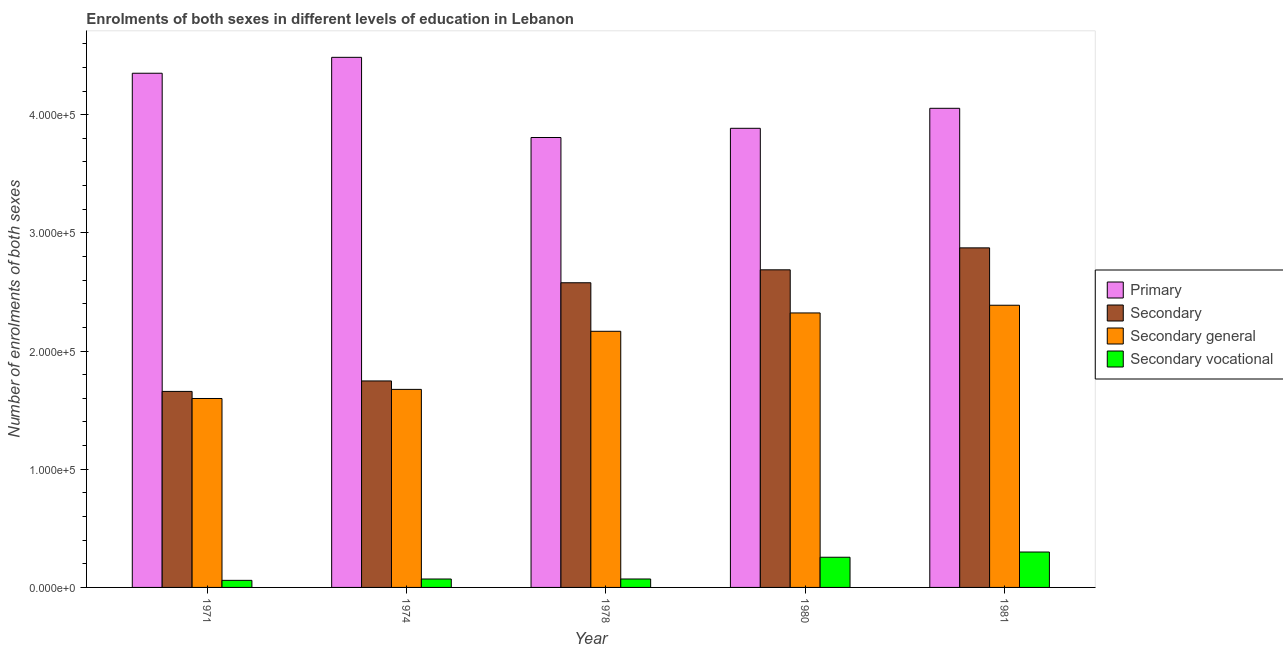How many groups of bars are there?
Provide a succinct answer. 5. Are the number of bars on each tick of the X-axis equal?
Ensure brevity in your answer.  Yes. How many bars are there on the 4th tick from the left?
Ensure brevity in your answer.  4. How many bars are there on the 1st tick from the right?
Your answer should be very brief. 4. What is the number of enrolments in secondary education in 1980?
Provide a succinct answer. 2.69e+05. Across all years, what is the maximum number of enrolments in secondary education?
Provide a succinct answer. 2.87e+05. Across all years, what is the minimum number of enrolments in secondary general education?
Your answer should be very brief. 1.60e+05. In which year was the number of enrolments in secondary education maximum?
Offer a terse response. 1981. What is the total number of enrolments in primary education in the graph?
Your response must be concise. 2.06e+06. What is the difference between the number of enrolments in secondary education in 1974 and that in 1980?
Your answer should be very brief. -9.40e+04. What is the difference between the number of enrolments in secondary general education in 1971 and the number of enrolments in secondary education in 1974?
Make the answer very short. -7707. What is the average number of enrolments in secondary education per year?
Ensure brevity in your answer.  2.31e+05. In how many years, is the number of enrolments in primary education greater than 180000?
Provide a succinct answer. 5. What is the ratio of the number of enrolments in secondary vocational education in 1980 to that in 1981?
Your answer should be very brief. 0.85. Is the difference between the number of enrolments in secondary vocational education in 1971 and 1981 greater than the difference between the number of enrolments in primary education in 1971 and 1981?
Your answer should be compact. No. What is the difference between the highest and the second highest number of enrolments in primary education?
Provide a succinct answer. 1.35e+04. What is the difference between the highest and the lowest number of enrolments in primary education?
Your answer should be compact. 6.78e+04. Is the sum of the number of enrolments in secondary education in 1971 and 1978 greater than the maximum number of enrolments in secondary vocational education across all years?
Your answer should be compact. Yes. Is it the case that in every year, the sum of the number of enrolments in secondary general education and number of enrolments in primary education is greater than the sum of number of enrolments in secondary vocational education and number of enrolments in secondary education?
Offer a terse response. Yes. What does the 4th bar from the left in 1980 represents?
Your response must be concise. Secondary vocational. What does the 1st bar from the right in 1974 represents?
Provide a succinct answer. Secondary vocational. Is it the case that in every year, the sum of the number of enrolments in primary education and number of enrolments in secondary education is greater than the number of enrolments in secondary general education?
Provide a short and direct response. Yes. How many years are there in the graph?
Your answer should be compact. 5. Are the values on the major ticks of Y-axis written in scientific E-notation?
Provide a short and direct response. Yes. Does the graph contain grids?
Provide a succinct answer. No. How are the legend labels stacked?
Your answer should be very brief. Vertical. What is the title of the graph?
Make the answer very short. Enrolments of both sexes in different levels of education in Lebanon. Does "Social equity" appear as one of the legend labels in the graph?
Keep it short and to the point. No. What is the label or title of the Y-axis?
Offer a terse response. Number of enrolments of both sexes. What is the Number of enrolments of both sexes in Primary in 1971?
Your answer should be compact. 4.35e+05. What is the Number of enrolments of both sexes of Secondary in 1971?
Offer a very short reply. 1.66e+05. What is the Number of enrolments of both sexes in Secondary general in 1971?
Your response must be concise. 1.60e+05. What is the Number of enrolments of both sexes of Secondary vocational in 1971?
Make the answer very short. 5983. What is the Number of enrolments of both sexes of Primary in 1974?
Keep it short and to the point. 4.49e+05. What is the Number of enrolments of both sexes in Secondary in 1974?
Offer a very short reply. 1.75e+05. What is the Number of enrolments of both sexes in Secondary general in 1974?
Give a very brief answer. 1.68e+05. What is the Number of enrolments of both sexes of Secondary vocational in 1974?
Offer a terse response. 7117. What is the Number of enrolments of both sexes in Primary in 1978?
Your answer should be very brief. 3.81e+05. What is the Number of enrolments of both sexes in Secondary in 1978?
Make the answer very short. 2.58e+05. What is the Number of enrolments of both sexes of Secondary general in 1978?
Provide a short and direct response. 2.17e+05. What is the Number of enrolments of both sexes in Secondary vocational in 1978?
Your answer should be very brief. 7133. What is the Number of enrolments of both sexes of Primary in 1980?
Offer a terse response. 3.88e+05. What is the Number of enrolments of both sexes in Secondary in 1980?
Make the answer very short. 2.69e+05. What is the Number of enrolments of both sexes in Secondary general in 1980?
Keep it short and to the point. 2.32e+05. What is the Number of enrolments of both sexes of Secondary vocational in 1980?
Offer a terse response. 2.55e+04. What is the Number of enrolments of both sexes in Primary in 1981?
Provide a succinct answer. 4.05e+05. What is the Number of enrolments of both sexes in Secondary in 1981?
Provide a short and direct response. 2.87e+05. What is the Number of enrolments of both sexes of Secondary general in 1981?
Give a very brief answer. 2.39e+05. What is the Number of enrolments of both sexes in Secondary vocational in 1981?
Your answer should be very brief. 3.00e+04. Across all years, what is the maximum Number of enrolments of both sexes of Primary?
Ensure brevity in your answer.  4.49e+05. Across all years, what is the maximum Number of enrolments of both sexes of Secondary?
Keep it short and to the point. 2.87e+05. Across all years, what is the maximum Number of enrolments of both sexes of Secondary general?
Provide a short and direct response. 2.39e+05. Across all years, what is the maximum Number of enrolments of both sexes of Secondary vocational?
Your response must be concise. 3.00e+04. Across all years, what is the minimum Number of enrolments of both sexes in Primary?
Offer a very short reply. 3.81e+05. Across all years, what is the minimum Number of enrolments of both sexes in Secondary?
Your answer should be very brief. 1.66e+05. Across all years, what is the minimum Number of enrolments of both sexes of Secondary general?
Your answer should be compact. 1.60e+05. Across all years, what is the minimum Number of enrolments of both sexes in Secondary vocational?
Offer a terse response. 5983. What is the total Number of enrolments of both sexes of Primary in the graph?
Provide a short and direct response. 2.06e+06. What is the total Number of enrolments of both sexes in Secondary in the graph?
Make the answer very short. 1.15e+06. What is the total Number of enrolments of both sexes of Secondary general in the graph?
Make the answer very short. 1.02e+06. What is the total Number of enrolments of both sexes in Secondary vocational in the graph?
Keep it short and to the point. 7.57e+04. What is the difference between the Number of enrolments of both sexes in Primary in 1971 and that in 1974?
Your response must be concise. -1.35e+04. What is the difference between the Number of enrolments of both sexes of Secondary in 1971 and that in 1974?
Give a very brief answer. -8857. What is the difference between the Number of enrolments of both sexes in Secondary general in 1971 and that in 1974?
Give a very brief answer. -7707. What is the difference between the Number of enrolments of both sexes in Secondary vocational in 1971 and that in 1974?
Offer a very short reply. -1134. What is the difference between the Number of enrolments of both sexes of Primary in 1971 and that in 1978?
Offer a terse response. 5.44e+04. What is the difference between the Number of enrolments of both sexes in Secondary in 1971 and that in 1978?
Provide a short and direct response. -9.19e+04. What is the difference between the Number of enrolments of both sexes of Secondary general in 1971 and that in 1978?
Provide a succinct answer. -5.69e+04. What is the difference between the Number of enrolments of both sexes in Secondary vocational in 1971 and that in 1978?
Provide a short and direct response. -1150. What is the difference between the Number of enrolments of both sexes in Primary in 1971 and that in 1980?
Offer a terse response. 4.66e+04. What is the difference between the Number of enrolments of both sexes of Secondary in 1971 and that in 1980?
Make the answer very short. -1.03e+05. What is the difference between the Number of enrolments of both sexes in Secondary general in 1971 and that in 1980?
Offer a very short reply. -7.24e+04. What is the difference between the Number of enrolments of both sexes of Secondary vocational in 1971 and that in 1980?
Make the answer very short. -1.96e+04. What is the difference between the Number of enrolments of both sexes of Primary in 1971 and that in 1981?
Provide a short and direct response. 2.97e+04. What is the difference between the Number of enrolments of both sexes of Secondary in 1971 and that in 1981?
Your answer should be compact. -1.21e+05. What is the difference between the Number of enrolments of both sexes in Secondary general in 1971 and that in 1981?
Offer a terse response. -7.89e+04. What is the difference between the Number of enrolments of both sexes in Secondary vocational in 1971 and that in 1981?
Your response must be concise. -2.40e+04. What is the difference between the Number of enrolments of both sexes in Primary in 1974 and that in 1978?
Offer a very short reply. 6.78e+04. What is the difference between the Number of enrolments of both sexes of Secondary in 1974 and that in 1978?
Keep it short and to the point. -8.31e+04. What is the difference between the Number of enrolments of both sexes of Secondary general in 1974 and that in 1978?
Your response must be concise. -4.92e+04. What is the difference between the Number of enrolments of both sexes of Primary in 1974 and that in 1980?
Your response must be concise. 6.01e+04. What is the difference between the Number of enrolments of both sexes in Secondary in 1974 and that in 1980?
Keep it short and to the point. -9.40e+04. What is the difference between the Number of enrolments of both sexes of Secondary general in 1974 and that in 1980?
Offer a terse response. -6.47e+04. What is the difference between the Number of enrolments of both sexes in Secondary vocational in 1974 and that in 1980?
Make the answer very short. -1.84e+04. What is the difference between the Number of enrolments of both sexes in Primary in 1974 and that in 1981?
Offer a very short reply. 4.31e+04. What is the difference between the Number of enrolments of both sexes of Secondary in 1974 and that in 1981?
Ensure brevity in your answer.  -1.13e+05. What is the difference between the Number of enrolments of both sexes in Secondary general in 1974 and that in 1981?
Ensure brevity in your answer.  -7.12e+04. What is the difference between the Number of enrolments of both sexes of Secondary vocational in 1974 and that in 1981?
Your answer should be compact. -2.28e+04. What is the difference between the Number of enrolments of both sexes in Primary in 1978 and that in 1980?
Make the answer very short. -7787. What is the difference between the Number of enrolments of both sexes of Secondary in 1978 and that in 1980?
Keep it short and to the point. -1.09e+04. What is the difference between the Number of enrolments of both sexes in Secondary general in 1978 and that in 1980?
Your answer should be very brief. -1.55e+04. What is the difference between the Number of enrolments of both sexes in Secondary vocational in 1978 and that in 1980?
Offer a very short reply. -1.84e+04. What is the difference between the Number of enrolments of both sexes of Primary in 1978 and that in 1981?
Make the answer very short. -2.47e+04. What is the difference between the Number of enrolments of both sexes of Secondary in 1978 and that in 1981?
Make the answer very short. -2.95e+04. What is the difference between the Number of enrolments of both sexes of Secondary general in 1978 and that in 1981?
Offer a very short reply. -2.20e+04. What is the difference between the Number of enrolments of both sexes in Secondary vocational in 1978 and that in 1981?
Ensure brevity in your answer.  -2.28e+04. What is the difference between the Number of enrolments of both sexes of Primary in 1980 and that in 1981?
Ensure brevity in your answer.  -1.69e+04. What is the difference between the Number of enrolments of both sexes of Secondary in 1980 and that in 1981?
Provide a short and direct response. -1.86e+04. What is the difference between the Number of enrolments of both sexes of Secondary general in 1980 and that in 1981?
Your response must be concise. -6518. What is the difference between the Number of enrolments of both sexes in Secondary vocational in 1980 and that in 1981?
Make the answer very short. -4417. What is the difference between the Number of enrolments of both sexes in Primary in 1971 and the Number of enrolments of both sexes in Secondary in 1974?
Provide a short and direct response. 2.60e+05. What is the difference between the Number of enrolments of both sexes in Primary in 1971 and the Number of enrolments of both sexes in Secondary general in 1974?
Ensure brevity in your answer.  2.67e+05. What is the difference between the Number of enrolments of both sexes in Primary in 1971 and the Number of enrolments of both sexes in Secondary vocational in 1974?
Your answer should be compact. 4.28e+05. What is the difference between the Number of enrolments of both sexes in Secondary in 1971 and the Number of enrolments of both sexes in Secondary general in 1974?
Provide a succinct answer. -1724. What is the difference between the Number of enrolments of both sexes in Secondary in 1971 and the Number of enrolments of both sexes in Secondary vocational in 1974?
Provide a succinct answer. 1.59e+05. What is the difference between the Number of enrolments of both sexes in Secondary general in 1971 and the Number of enrolments of both sexes in Secondary vocational in 1974?
Ensure brevity in your answer.  1.53e+05. What is the difference between the Number of enrolments of both sexes in Primary in 1971 and the Number of enrolments of both sexes in Secondary in 1978?
Provide a short and direct response. 1.77e+05. What is the difference between the Number of enrolments of both sexes in Primary in 1971 and the Number of enrolments of both sexes in Secondary general in 1978?
Give a very brief answer. 2.18e+05. What is the difference between the Number of enrolments of both sexes of Primary in 1971 and the Number of enrolments of both sexes of Secondary vocational in 1978?
Your answer should be compact. 4.28e+05. What is the difference between the Number of enrolments of both sexes of Secondary in 1971 and the Number of enrolments of both sexes of Secondary general in 1978?
Your response must be concise. -5.09e+04. What is the difference between the Number of enrolments of both sexes of Secondary in 1971 and the Number of enrolments of both sexes of Secondary vocational in 1978?
Keep it short and to the point. 1.59e+05. What is the difference between the Number of enrolments of both sexes in Secondary general in 1971 and the Number of enrolments of both sexes in Secondary vocational in 1978?
Offer a terse response. 1.53e+05. What is the difference between the Number of enrolments of both sexes in Primary in 1971 and the Number of enrolments of both sexes in Secondary in 1980?
Provide a succinct answer. 1.66e+05. What is the difference between the Number of enrolments of both sexes in Primary in 1971 and the Number of enrolments of both sexes in Secondary general in 1980?
Ensure brevity in your answer.  2.03e+05. What is the difference between the Number of enrolments of both sexes of Primary in 1971 and the Number of enrolments of both sexes of Secondary vocational in 1980?
Offer a very short reply. 4.10e+05. What is the difference between the Number of enrolments of both sexes of Secondary in 1971 and the Number of enrolments of both sexes of Secondary general in 1980?
Offer a very short reply. -6.64e+04. What is the difference between the Number of enrolments of both sexes of Secondary in 1971 and the Number of enrolments of both sexes of Secondary vocational in 1980?
Your response must be concise. 1.40e+05. What is the difference between the Number of enrolments of both sexes of Secondary general in 1971 and the Number of enrolments of both sexes of Secondary vocational in 1980?
Offer a terse response. 1.34e+05. What is the difference between the Number of enrolments of both sexes in Primary in 1971 and the Number of enrolments of both sexes in Secondary in 1981?
Ensure brevity in your answer.  1.48e+05. What is the difference between the Number of enrolments of both sexes in Primary in 1971 and the Number of enrolments of both sexes in Secondary general in 1981?
Your answer should be very brief. 1.96e+05. What is the difference between the Number of enrolments of both sexes in Primary in 1971 and the Number of enrolments of both sexes in Secondary vocational in 1981?
Offer a terse response. 4.05e+05. What is the difference between the Number of enrolments of both sexes of Secondary in 1971 and the Number of enrolments of both sexes of Secondary general in 1981?
Provide a succinct answer. -7.29e+04. What is the difference between the Number of enrolments of both sexes of Secondary in 1971 and the Number of enrolments of both sexes of Secondary vocational in 1981?
Offer a terse response. 1.36e+05. What is the difference between the Number of enrolments of both sexes in Secondary general in 1971 and the Number of enrolments of both sexes in Secondary vocational in 1981?
Provide a succinct answer. 1.30e+05. What is the difference between the Number of enrolments of both sexes in Primary in 1974 and the Number of enrolments of both sexes in Secondary in 1978?
Offer a terse response. 1.91e+05. What is the difference between the Number of enrolments of both sexes of Primary in 1974 and the Number of enrolments of both sexes of Secondary general in 1978?
Ensure brevity in your answer.  2.32e+05. What is the difference between the Number of enrolments of both sexes in Primary in 1974 and the Number of enrolments of both sexes in Secondary vocational in 1978?
Keep it short and to the point. 4.41e+05. What is the difference between the Number of enrolments of both sexes of Secondary in 1974 and the Number of enrolments of both sexes of Secondary general in 1978?
Your response must be concise. -4.20e+04. What is the difference between the Number of enrolments of both sexes in Secondary in 1974 and the Number of enrolments of both sexes in Secondary vocational in 1978?
Offer a terse response. 1.68e+05. What is the difference between the Number of enrolments of both sexes in Secondary general in 1974 and the Number of enrolments of both sexes in Secondary vocational in 1978?
Make the answer very short. 1.60e+05. What is the difference between the Number of enrolments of both sexes in Primary in 1974 and the Number of enrolments of both sexes in Secondary in 1980?
Ensure brevity in your answer.  1.80e+05. What is the difference between the Number of enrolments of both sexes of Primary in 1974 and the Number of enrolments of both sexes of Secondary general in 1980?
Offer a very short reply. 2.16e+05. What is the difference between the Number of enrolments of both sexes of Primary in 1974 and the Number of enrolments of both sexes of Secondary vocational in 1980?
Offer a terse response. 4.23e+05. What is the difference between the Number of enrolments of both sexes in Secondary in 1974 and the Number of enrolments of both sexes in Secondary general in 1980?
Offer a terse response. -5.75e+04. What is the difference between the Number of enrolments of both sexes of Secondary in 1974 and the Number of enrolments of both sexes of Secondary vocational in 1980?
Keep it short and to the point. 1.49e+05. What is the difference between the Number of enrolments of both sexes of Secondary general in 1974 and the Number of enrolments of both sexes of Secondary vocational in 1980?
Ensure brevity in your answer.  1.42e+05. What is the difference between the Number of enrolments of both sexes in Primary in 1974 and the Number of enrolments of both sexes in Secondary in 1981?
Give a very brief answer. 1.61e+05. What is the difference between the Number of enrolments of both sexes of Primary in 1974 and the Number of enrolments of both sexes of Secondary general in 1981?
Ensure brevity in your answer.  2.10e+05. What is the difference between the Number of enrolments of both sexes of Primary in 1974 and the Number of enrolments of both sexes of Secondary vocational in 1981?
Your answer should be very brief. 4.19e+05. What is the difference between the Number of enrolments of both sexes of Secondary in 1974 and the Number of enrolments of both sexes of Secondary general in 1981?
Keep it short and to the point. -6.41e+04. What is the difference between the Number of enrolments of both sexes of Secondary in 1974 and the Number of enrolments of both sexes of Secondary vocational in 1981?
Keep it short and to the point. 1.45e+05. What is the difference between the Number of enrolments of both sexes in Secondary general in 1974 and the Number of enrolments of both sexes in Secondary vocational in 1981?
Keep it short and to the point. 1.38e+05. What is the difference between the Number of enrolments of both sexes of Primary in 1978 and the Number of enrolments of both sexes of Secondary in 1980?
Your response must be concise. 1.12e+05. What is the difference between the Number of enrolments of both sexes of Primary in 1978 and the Number of enrolments of both sexes of Secondary general in 1980?
Make the answer very short. 1.48e+05. What is the difference between the Number of enrolments of both sexes in Primary in 1978 and the Number of enrolments of both sexes in Secondary vocational in 1980?
Keep it short and to the point. 3.55e+05. What is the difference between the Number of enrolments of both sexes in Secondary in 1978 and the Number of enrolments of both sexes in Secondary general in 1980?
Offer a very short reply. 2.55e+04. What is the difference between the Number of enrolments of both sexes of Secondary in 1978 and the Number of enrolments of both sexes of Secondary vocational in 1980?
Offer a terse response. 2.32e+05. What is the difference between the Number of enrolments of both sexes of Secondary general in 1978 and the Number of enrolments of both sexes of Secondary vocational in 1980?
Offer a very short reply. 1.91e+05. What is the difference between the Number of enrolments of both sexes in Primary in 1978 and the Number of enrolments of both sexes in Secondary in 1981?
Provide a short and direct response. 9.34e+04. What is the difference between the Number of enrolments of both sexes in Primary in 1978 and the Number of enrolments of both sexes in Secondary general in 1981?
Your answer should be compact. 1.42e+05. What is the difference between the Number of enrolments of both sexes of Primary in 1978 and the Number of enrolments of both sexes of Secondary vocational in 1981?
Ensure brevity in your answer.  3.51e+05. What is the difference between the Number of enrolments of both sexes of Secondary in 1978 and the Number of enrolments of both sexes of Secondary general in 1981?
Your answer should be very brief. 1.90e+04. What is the difference between the Number of enrolments of both sexes in Secondary in 1978 and the Number of enrolments of both sexes in Secondary vocational in 1981?
Make the answer very short. 2.28e+05. What is the difference between the Number of enrolments of both sexes of Secondary general in 1978 and the Number of enrolments of both sexes of Secondary vocational in 1981?
Your response must be concise. 1.87e+05. What is the difference between the Number of enrolments of both sexes in Primary in 1980 and the Number of enrolments of both sexes in Secondary in 1981?
Provide a short and direct response. 1.01e+05. What is the difference between the Number of enrolments of both sexes of Primary in 1980 and the Number of enrolments of both sexes of Secondary general in 1981?
Your response must be concise. 1.50e+05. What is the difference between the Number of enrolments of both sexes of Primary in 1980 and the Number of enrolments of both sexes of Secondary vocational in 1981?
Your answer should be compact. 3.59e+05. What is the difference between the Number of enrolments of both sexes in Secondary in 1980 and the Number of enrolments of both sexes in Secondary general in 1981?
Offer a very short reply. 3.00e+04. What is the difference between the Number of enrolments of both sexes in Secondary in 1980 and the Number of enrolments of both sexes in Secondary vocational in 1981?
Offer a terse response. 2.39e+05. What is the difference between the Number of enrolments of both sexes in Secondary general in 1980 and the Number of enrolments of both sexes in Secondary vocational in 1981?
Ensure brevity in your answer.  2.02e+05. What is the average Number of enrolments of both sexes of Primary per year?
Your answer should be very brief. 4.12e+05. What is the average Number of enrolments of both sexes in Secondary per year?
Provide a succinct answer. 2.31e+05. What is the average Number of enrolments of both sexes of Secondary general per year?
Provide a short and direct response. 2.03e+05. What is the average Number of enrolments of both sexes of Secondary vocational per year?
Your answer should be compact. 1.51e+04. In the year 1971, what is the difference between the Number of enrolments of both sexes of Primary and Number of enrolments of both sexes of Secondary?
Your answer should be very brief. 2.69e+05. In the year 1971, what is the difference between the Number of enrolments of both sexes in Primary and Number of enrolments of both sexes in Secondary general?
Make the answer very short. 2.75e+05. In the year 1971, what is the difference between the Number of enrolments of both sexes in Primary and Number of enrolments of both sexes in Secondary vocational?
Your response must be concise. 4.29e+05. In the year 1971, what is the difference between the Number of enrolments of both sexes of Secondary and Number of enrolments of both sexes of Secondary general?
Give a very brief answer. 5983. In the year 1971, what is the difference between the Number of enrolments of both sexes in Secondary and Number of enrolments of both sexes in Secondary vocational?
Give a very brief answer. 1.60e+05. In the year 1971, what is the difference between the Number of enrolments of both sexes of Secondary general and Number of enrolments of both sexes of Secondary vocational?
Your answer should be compact. 1.54e+05. In the year 1974, what is the difference between the Number of enrolments of both sexes of Primary and Number of enrolments of both sexes of Secondary?
Give a very brief answer. 2.74e+05. In the year 1974, what is the difference between the Number of enrolments of both sexes of Primary and Number of enrolments of both sexes of Secondary general?
Your answer should be compact. 2.81e+05. In the year 1974, what is the difference between the Number of enrolments of both sexes in Primary and Number of enrolments of both sexes in Secondary vocational?
Your answer should be compact. 4.41e+05. In the year 1974, what is the difference between the Number of enrolments of both sexes in Secondary and Number of enrolments of both sexes in Secondary general?
Provide a short and direct response. 7133. In the year 1974, what is the difference between the Number of enrolments of both sexes in Secondary and Number of enrolments of both sexes in Secondary vocational?
Your response must be concise. 1.68e+05. In the year 1974, what is the difference between the Number of enrolments of both sexes of Secondary general and Number of enrolments of both sexes of Secondary vocational?
Give a very brief answer. 1.60e+05. In the year 1978, what is the difference between the Number of enrolments of both sexes in Primary and Number of enrolments of both sexes in Secondary?
Give a very brief answer. 1.23e+05. In the year 1978, what is the difference between the Number of enrolments of both sexes in Primary and Number of enrolments of both sexes in Secondary general?
Your answer should be compact. 1.64e+05. In the year 1978, what is the difference between the Number of enrolments of both sexes in Primary and Number of enrolments of both sexes in Secondary vocational?
Make the answer very short. 3.74e+05. In the year 1978, what is the difference between the Number of enrolments of both sexes in Secondary and Number of enrolments of both sexes in Secondary general?
Give a very brief answer. 4.11e+04. In the year 1978, what is the difference between the Number of enrolments of both sexes of Secondary and Number of enrolments of both sexes of Secondary vocational?
Your answer should be compact. 2.51e+05. In the year 1978, what is the difference between the Number of enrolments of both sexes of Secondary general and Number of enrolments of both sexes of Secondary vocational?
Keep it short and to the point. 2.10e+05. In the year 1980, what is the difference between the Number of enrolments of both sexes of Primary and Number of enrolments of both sexes of Secondary?
Ensure brevity in your answer.  1.20e+05. In the year 1980, what is the difference between the Number of enrolments of both sexes of Primary and Number of enrolments of both sexes of Secondary general?
Make the answer very short. 1.56e+05. In the year 1980, what is the difference between the Number of enrolments of both sexes of Primary and Number of enrolments of both sexes of Secondary vocational?
Provide a succinct answer. 3.63e+05. In the year 1980, what is the difference between the Number of enrolments of both sexes of Secondary and Number of enrolments of both sexes of Secondary general?
Keep it short and to the point. 3.65e+04. In the year 1980, what is the difference between the Number of enrolments of both sexes in Secondary and Number of enrolments of both sexes in Secondary vocational?
Offer a terse response. 2.43e+05. In the year 1980, what is the difference between the Number of enrolments of both sexes of Secondary general and Number of enrolments of both sexes of Secondary vocational?
Provide a succinct answer. 2.07e+05. In the year 1981, what is the difference between the Number of enrolments of both sexes of Primary and Number of enrolments of both sexes of Secondary?
Provide a short and direct response. 1.18e+05. In the year 1981, what is the difference between the Number of enrolments of both sexes in Primary and Number of enrolments of both sexes in Secondary general?
Provide a short and direct response. 1.67e+05. In the year 1981, what is the difference between the Number of enrolments of both sexes of Primary and Number of enrolments of both sexes of Secondary vocational?
Ensure brevity in your answer.  3.75e+05. In the year 1981, what is the difference between the Number of enrolments of both sexes in Secondary and Number of enrolments of both sexes in Secondary general?
Offer a very short reply. 4.85e+04. In the year 1981, what is the difference between the Number of enrolments of both sexes in Secondary and Number of enrolments of both sexes in Secondary vocational?
Your answer should be compact. 2.57e+05. In the year 1981, what is the difference between the Number of enrolments of both sexes of Secondary general and Number of enrolments of both sexes of Secondary vocational?
Provide a short and direct response. 2.09e+05. What is the ratio of the Number of enrolments of both sexes in Secondary in 1971 to that in 1974?
Your answer should be compact. 0.95. What is the ratio of the Number of enrolments of both sexes in Secondary general in 1971 to that in 1974?
Provide a succinct answer. 0.95. What is the ratio of the Number of enrolments of both sexes in Secondary vocational in 1971 to that in 1974?
Provide a succinct answer. 0.84. What is the ratio of the Number of enrolments of both sexes in Primary in 1971 to that in 1978?
Keep it short and to the point. 1.14. What is the ratio of the Number of enrolments of both sexes of Secondary in 1971 to that in 1978?
Provide a short and direct response. 0.64. What is the ratio of the Number of enrolments of both sexes of Secondary general in 1971 to that in 1978?
Your answer should be compact. 0.74. What is the ratio of the Number of enrolments of both sexes of Secondary vocational in 1971 to that in 1978?
Make the answer very short. 0.84. What is the ratio of the Number of enrolments of both sexes in Primary in 1971 to that in 1980?
Give a very brief answer. 1.12. What is the ratio of the Number of enrolments of both sexes in Secondary in 1971 to that in 1980?
Offer a very short reply. 0.62. What is the ratio of the Number of enrolments of both sexes of Secondary general in 1971 to that in 1980?
Your response must be concise. 0.69. What is the ratio of the Number of enrolments of both sexes in Secondary vocational in 1971 to that in 1980?
Offer a very short reply. 0.23. What is the ratio of the Number of enrolments of both sexes in Primary in 1971 to that in 1981?
Your answer should be compact. 1.07. What is the ratio of the Number of enrolments of both sexes in Secondary in 1971 to that in 1981?
Provide a succinct answer. 0.58. What is the ratio of the Number of enrolments of both sexes in Secondary general in 1971 to that in 1981?
Offer a terse response. 0.67. What is the ratio of the Number of enrolments of both sexes in Secondary vocational in 1971 to that in 1981?
Provide a succinct answer. 0.2. What is the ratio of the Number of enrolments of both sexes of Primary in 1974 to that in 1978?
Offer a very short reply. 1.18. What is the ratio of the Number of enrolments of both sexes in Secondary in 1974 to that in 1978?
Provide a short and direct response. 0.68. What is the ratio of the Number of enrolments of both sexes in Secondary general in 1974 to that in 1978?
Provide a succinct answer. 0.77. What is the ratio of the Number of enrolments of both sexes in Secondary vocational in 1974 to that in 1978?
Your answer should be compact. 1. What is the ratio of the Number of enrolments of both sexes in Primary in 1974 to that in 1980?
Make the answer very short. 1.15. What is the ratio of the Number of enrolments of both sexes in Secondary in 1974 to that in 1980?
Keep it short and to the point. 0.65. What is the ratio of the Number of enrolments of both sexes of Secondary general in 1974 to that in 1980?
Offer a terse response. 0.72. What is the ratio of the Number of enrolments of both sexes in Secondary vocational in 1974 to that in 1980?
Provide a succinct answer. 0.28. What is the ratio of the Number of enrolments of both sexes in Primary in 1974 to that in 1981?
Make the answer very short. 1.11. What is the ratio of the Number of enrolments of both sexes of Secondary in 1974 to that in 1981?
Provide a succinct answer. 0.61. What is the ratio of the Number of enrolments of both sexes in Secondary general in 1974 to that in 1981?
Offer a terse response. 0.7. What is the ratio of the Number of enrolments of both sexes in Secondary vocational in 1974 to that in 1981?
Your answer should be compact. 0.24. What is the ratio of the Number of enrolments of both sexes of Secondary in 1978 to that in 1980?
Your answer should be very brief. 0.96. What is the ratio of the Number of enrolments of both sexes in Secondary general in 1978 to that in 1980?
Offer a terse response. 0.93. What is the ratio of the Number of enrolments of both sexes in Secondary vocational in 1978 to that in 1980?
Make the answer very short. 0.28. What is the ratio of the Number of enrolments of both sexes of Primary in 1978 to that in 1981?
Your answer should be compact. 0.94. What is the ratio of the Number of enrolments of both sexes of Secondary in 1978 to that in 1981?
Offer a terse response. 0.9. What is the ratio of the Number of enrolments of both sexes of Secondary general in 1978 to that in 1981?
Give a very brief answer. 0.91. What is the ratio of the Number of enrolments of both sexes of Secondary vocational in 1978 to that in 1981?
Make the answer very short. 0.24. What is the ratio of the Number of enrolments of both sexes of Primary in 1980 to that in 1981?
Your response must be concise. 0.96. What is the ratio of the Number of enrolments of both sexes of Secondary in 1980 to that in 1981?
Keep it short and to the point. 0.94. What is the ratio of the Number of enrolments of both sexes of Secondary general in 1980 to that in 1981?
Give a very brief answer. 0.97. What is the ratio of the Number of enrolments of both sexes of Secondary vocational in 1980 to that in 1981?
Offer a terse response. 0.85. What is the difference between the highest and the second highest Number of enrolments of both sexes of Primary?
Ensure brevity in your answer.  1.35e+04. What is the difference between the highest and the second highest Number of enrolments of both sexes in Secondary?
Offer a terse response. 1.86e+04. What is the difference between the highest and the second highest Number of enrolments of both sexes in Secondary general?
Give a very brief answer. 6518. What is the difference between the highest and the second highest Number of enrolments of both sexes of Secondary vocational?
Provide a succinct answer. 4417. What is the difference between the highest and the lowest Number of enrolments of both sexes in Primary?
Your answer should be compact. 6.78e+04. What is the difference between the highest and the lowest Number of enrolments of both sexes of Secondary?
Your response must be concise. 1.21e+05. What is the difference between the highest and the lowest Number of enrolments of both sexes of Secondary general?
Provide a succinct answer. 7.89e+04. What is the difference between the highest and the lowest Number of enrolments of both sexes in Secondary vocational?
Give a very brief answer. 2.40e+04. 